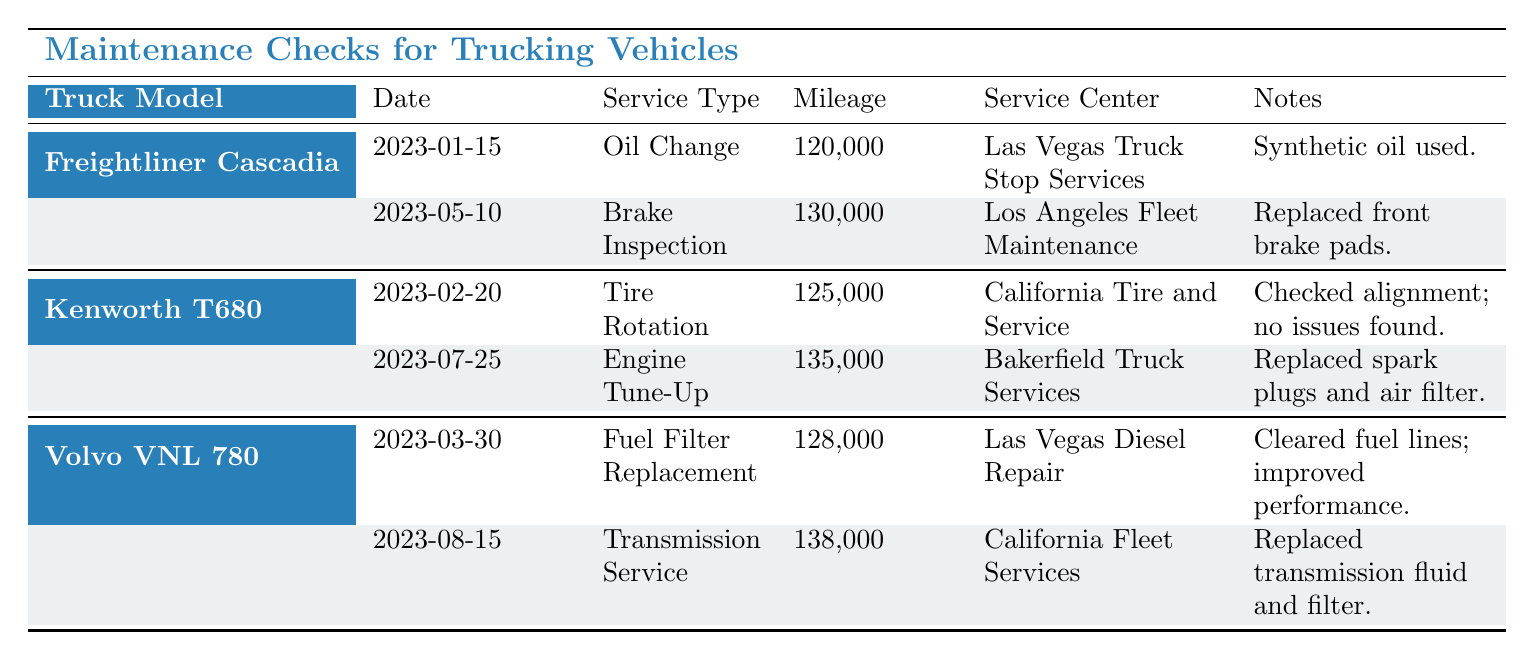What type of service was performed on the Freightliner Cascadia on January 15, 2023? The table indicates that the service performed on the Freightliner Cascadia on this date was an Oil Change.
Answer: Oil Change Which service center handled the engine tune-up for the Kenworth T680? According to the table, the engine tune-up for the Kenworth T680 was handled by Bakerfield Truck Services.
Answer: Bakerfield Truck Services How many service records are listed for the Volvo VNL 780? The table shows there are two service records listed for the Volvo VNL 780, one for Fuel Filter Replacement and one for Transmission Service.
Answer: 2 What is the difference in mileage between the last service for the Freightliner Cascadia and the last service for the Kenworth T680? The table shows the last service mileage for the Freightliner Cascadia was 130000 and for the Kenworth T680 it was 135000. The difference is 135000 - 130000 = 5000.
Answer: 5000 Did the Kenworth T680 receive a tire rotation after the Freightliner Cascadia's brake inspection? Yes, the tire rotation for the Kenworth T680 was performed on February 20, 2023, which is after the brake inspection of the Freightliner Cascadia on May 10, 2023.
Answer: Yes What was the most recent service done on the Volvo VNL 780 and its date? The most recent service for the Volvo VNL 780 was Transmission Service, performed on August 15, 2023.
Answer: Transmission Service on August 15, 2023 Which truck model had a service for brake inspection before the tire rotation for the Kenworth T680? The Freightliner Cascadia had a service for brake inspection on May 10, 2023, which occurred before the tire rotation of the Kenworth T680 done on February 20, 2023.
Answer: Freightliner Cascadia What type of service was performed most recently among all truck models? Looking at the table, the most recent service is the Transmission Service for the Volvo VNL 780 on August 15, 2023.
Answer: Transmission Service 